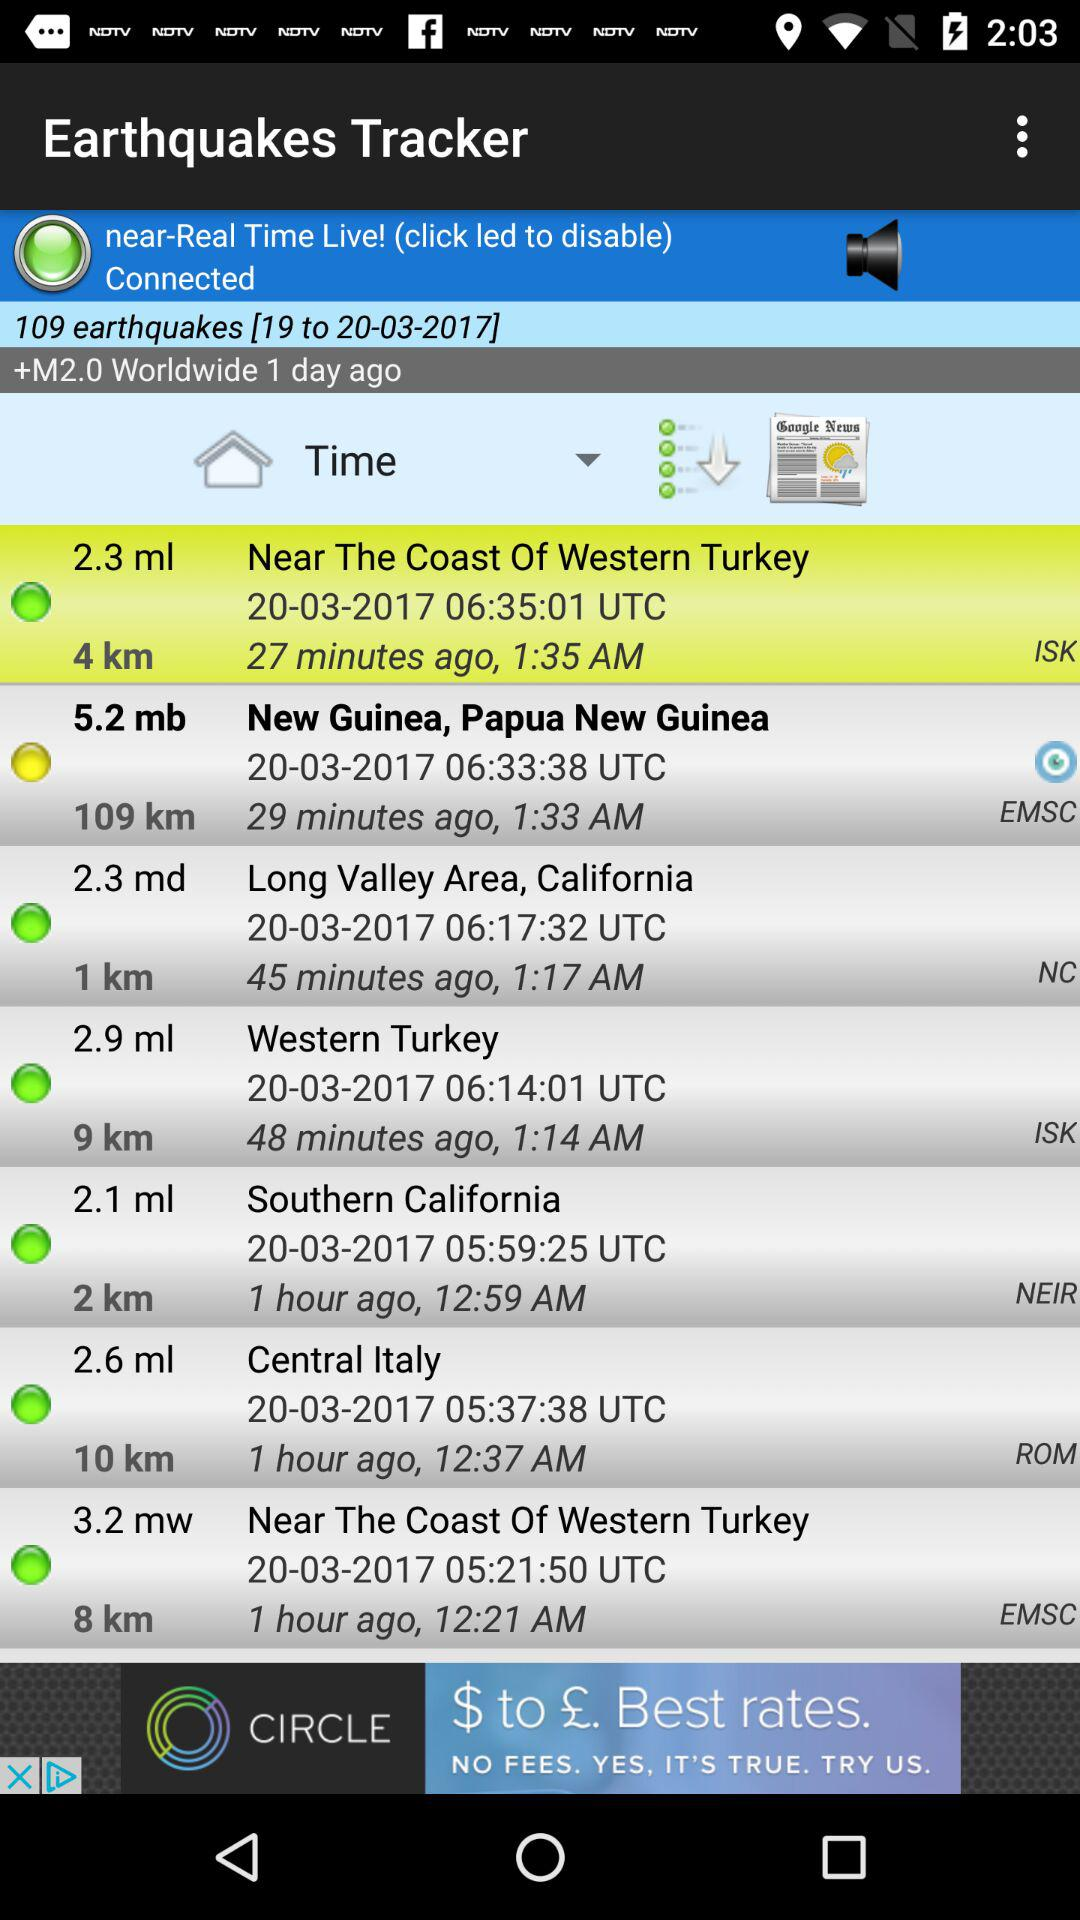How many earthquakes in total are there? There are 109 earthquakes in total. 